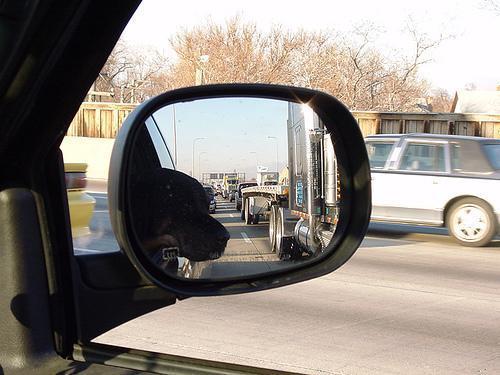How many trucks are in the photo?
Give a very brief answer. 1. How many dogs are visible?
Give a very brief answer. 1. How many cars can be seen?
Give a very brief answer. 2. 